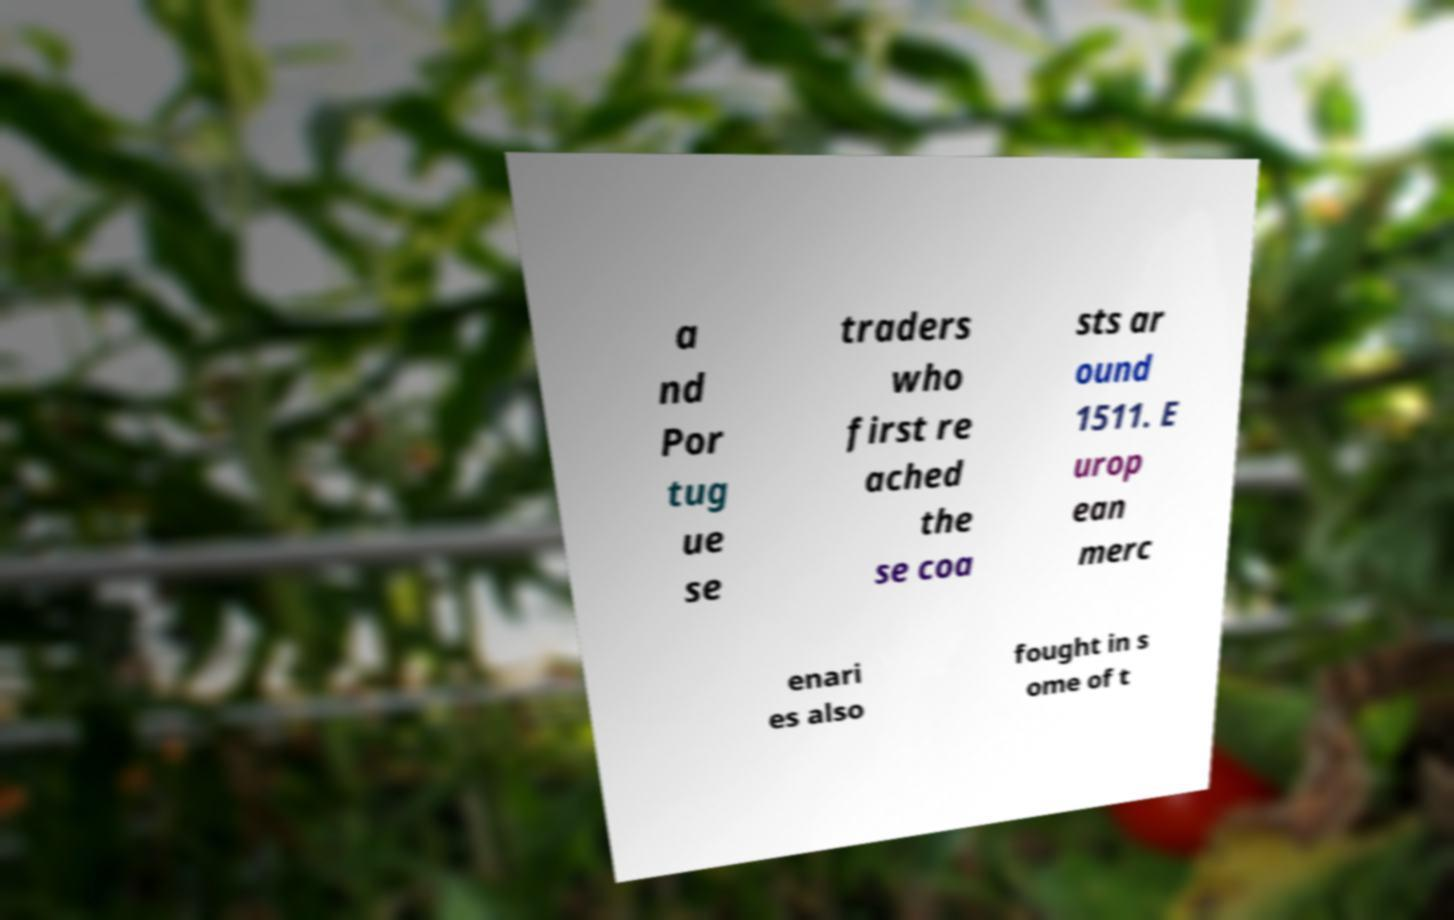What messages or text are displayed in this image? I need them in a readable, typed format. a nd Por tug ue se traders who first re ached the se coa sts ar ound 1511. E urop ean merc enari es also fought in s ome of t 